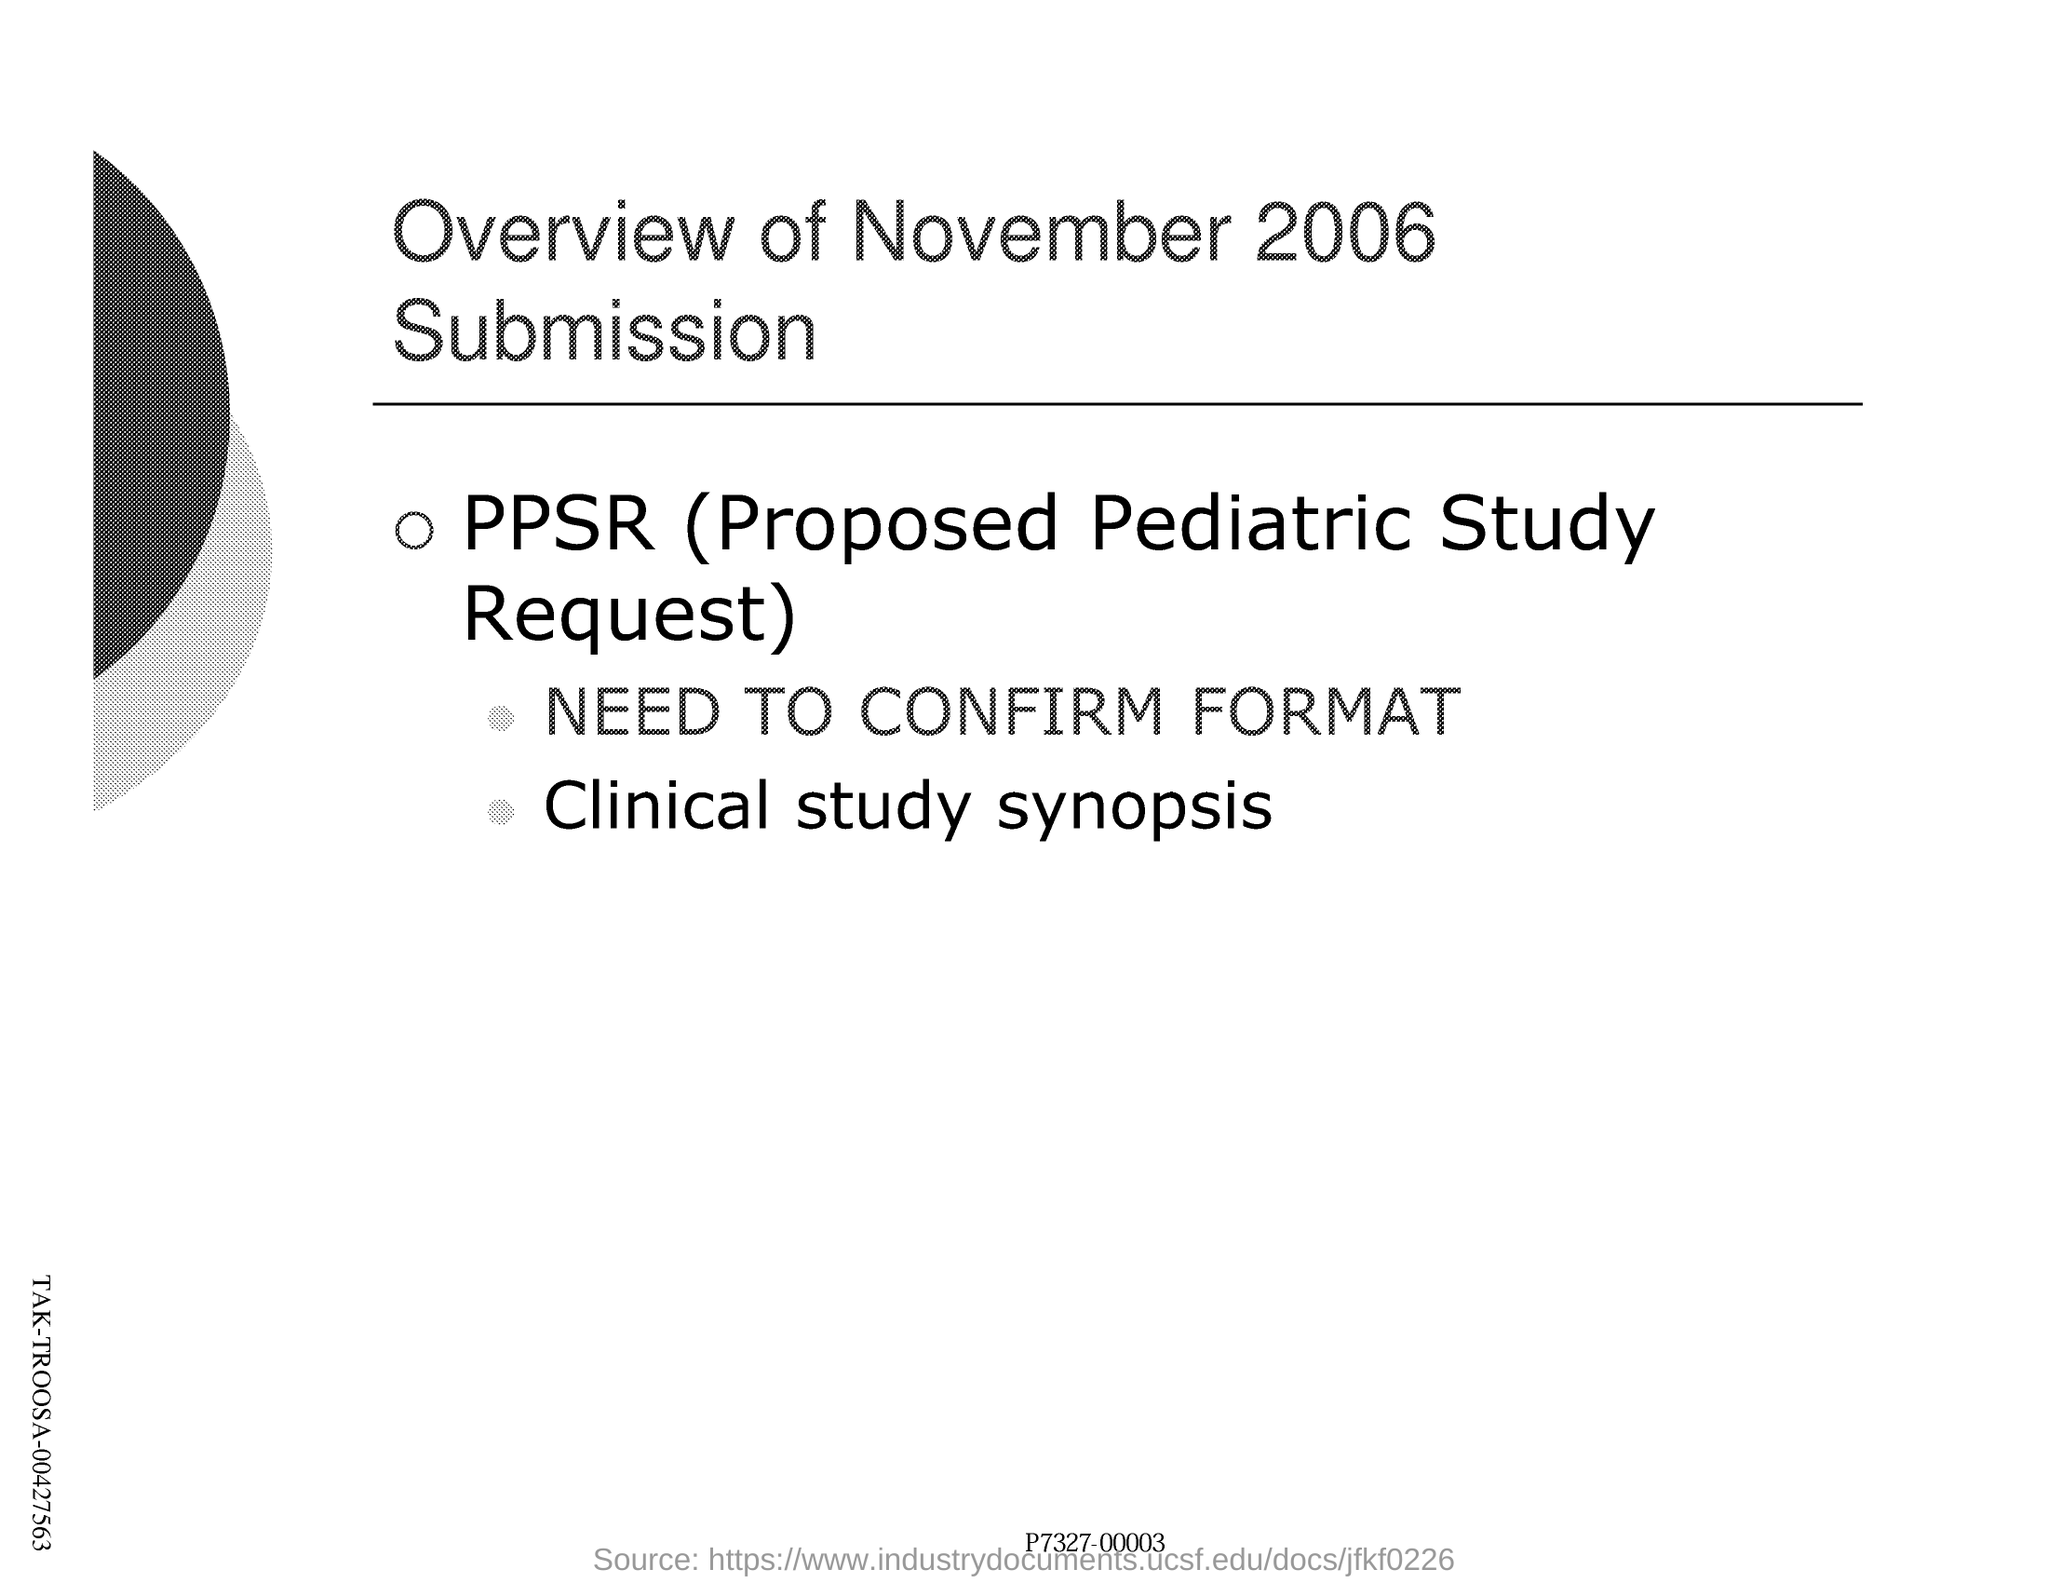What is the title of this document?
Provide a succinct answer. Overview of November 2006 Submission. What is the full form of PPSR?
Ensure brevity in your answer.  Proposed Pediatric Study Request. 